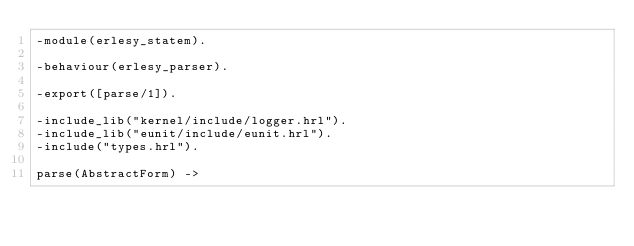Convert code to text. <code><loc_0><loc_0><loc_500><loc_500><_Erlang_>-module(erlesy_statem).

-behaviour(erlesy_parser).

-export([parse/1]).

-include_lib("kernel/include/logger.hrl").
-include_lib("eunit/include/eunit.hrl").
-include("types.hrl").

parse(AbstractForm) -></code> 